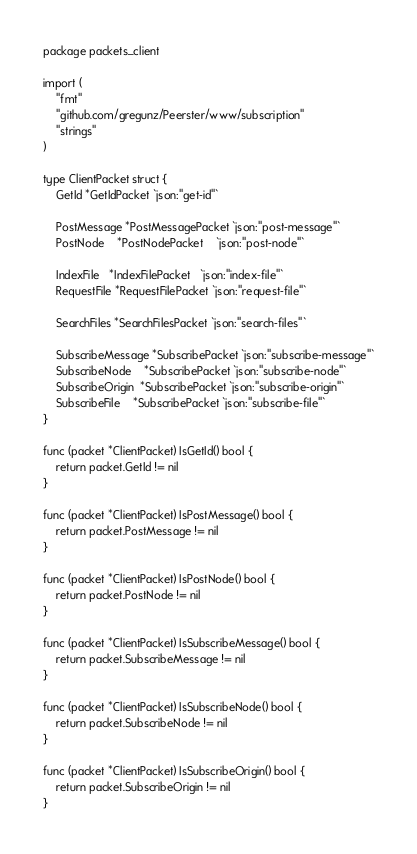Convert code to text. <code><loc_0><loc_0><loc_500><loc_500><_Go_>package packets_client

import (
	"fmt"
	"github.com/gregunz/Peerster/www/subscription"
	"strings"
)

type ClientPacket struct {
	GetId *GetIdPacket `json:"get-id"`

	PostMessage *PostMessagePacket `json:"post-message"`
	PostNode    *PostNodePacket    `json:"post-node"`

	IndexFile   *IndexFilePacket   `json:"index-file"`
	RequestFile *RequestFilePacket `json:"request-file"`

	SearchFiles *SearchFilesPacket `json:"search-files"`

	SubscribeMessage *SubscribePacket `json:"subscribe-message"`
	SubscribeNode    *SubscribePacket `json:"subscribe-node"`
	SubscribeOrigin  *SubscribePacket `json:"subscribe-origin"`
	SubscribeFile    *SubscribePacket `json:"subscribe-file"`
}

func (packet *ClientPacket) IsGetId() bool {
	return packet.GetId != nil
}

func (packet *ClientPacket) IsPostMessage() bool {
	return packet.PostMessage != nil
}

func (packet *ClientPacket) IsPostNode() bool {
	return packet.PostNode != nil
}

func (packet *ClientPacket) IsSubscribeMessage() bool {
	return packet.SubscribeMessage != nil
}

func (packet *ClientPacket) IsSubscribeNode() bool {
	return packet.SubscribeNode != nil
}

func (packet *ClientPacket) IsSubscribeOrigin() bool {
	return packet.SubscribeOrigin != nil
}
</code> 